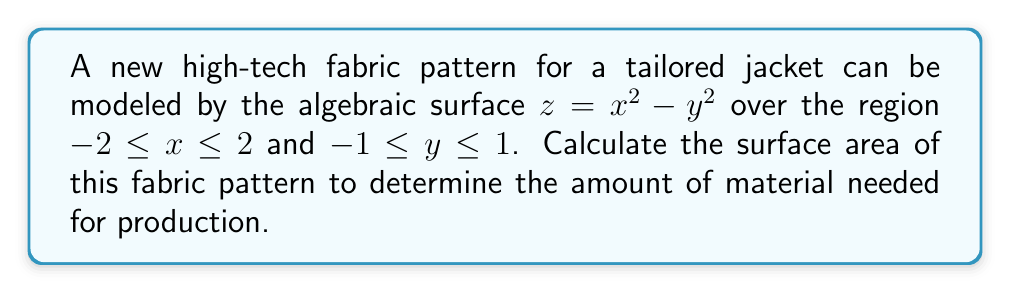Could you help me with this problem? To calculate the surface area of the fabric pattern, we need to use the surface area formula for a function $z = f(x,y)$:

$$A = \int\int_R \sqrt{1 + \left(\frac{\partial z}{\partial x}\right)^2 + \left(\frac{\partial z}{\partial y}\right)^2} \, dA$$

Where $R$ is the region of integration.

Step 1: Calculate the partial derivatives
$\frac{\partial z}{\partial x} = 2x$
$\frac{\partial z}{\partial y} = -2y$

Step 2: Substitute into the surface area formula
$$A = \int_{-1}^1 \int_{-2}^2 \sqrt{1 + (2x)^2 + (-2y)^2} \, dx \, dy$$

Step 3: Simplify the integrand
$$A = \int_{-1}^1 \int_{-2}^2 \sqrt{1 + 4x^2 + 4y^2} \, dx \, dy$$

Step 4: This integral is difficult to evaluate analytically. We can use numerical integration methods or computer algebra systems to approximate the result.

Using a numerical integration method, we find:
$$A \approx 13.416$$

Therefore, the surface area of the fabric pattern is approximately 13.416 square units.
Answer: $13.416$ square units 